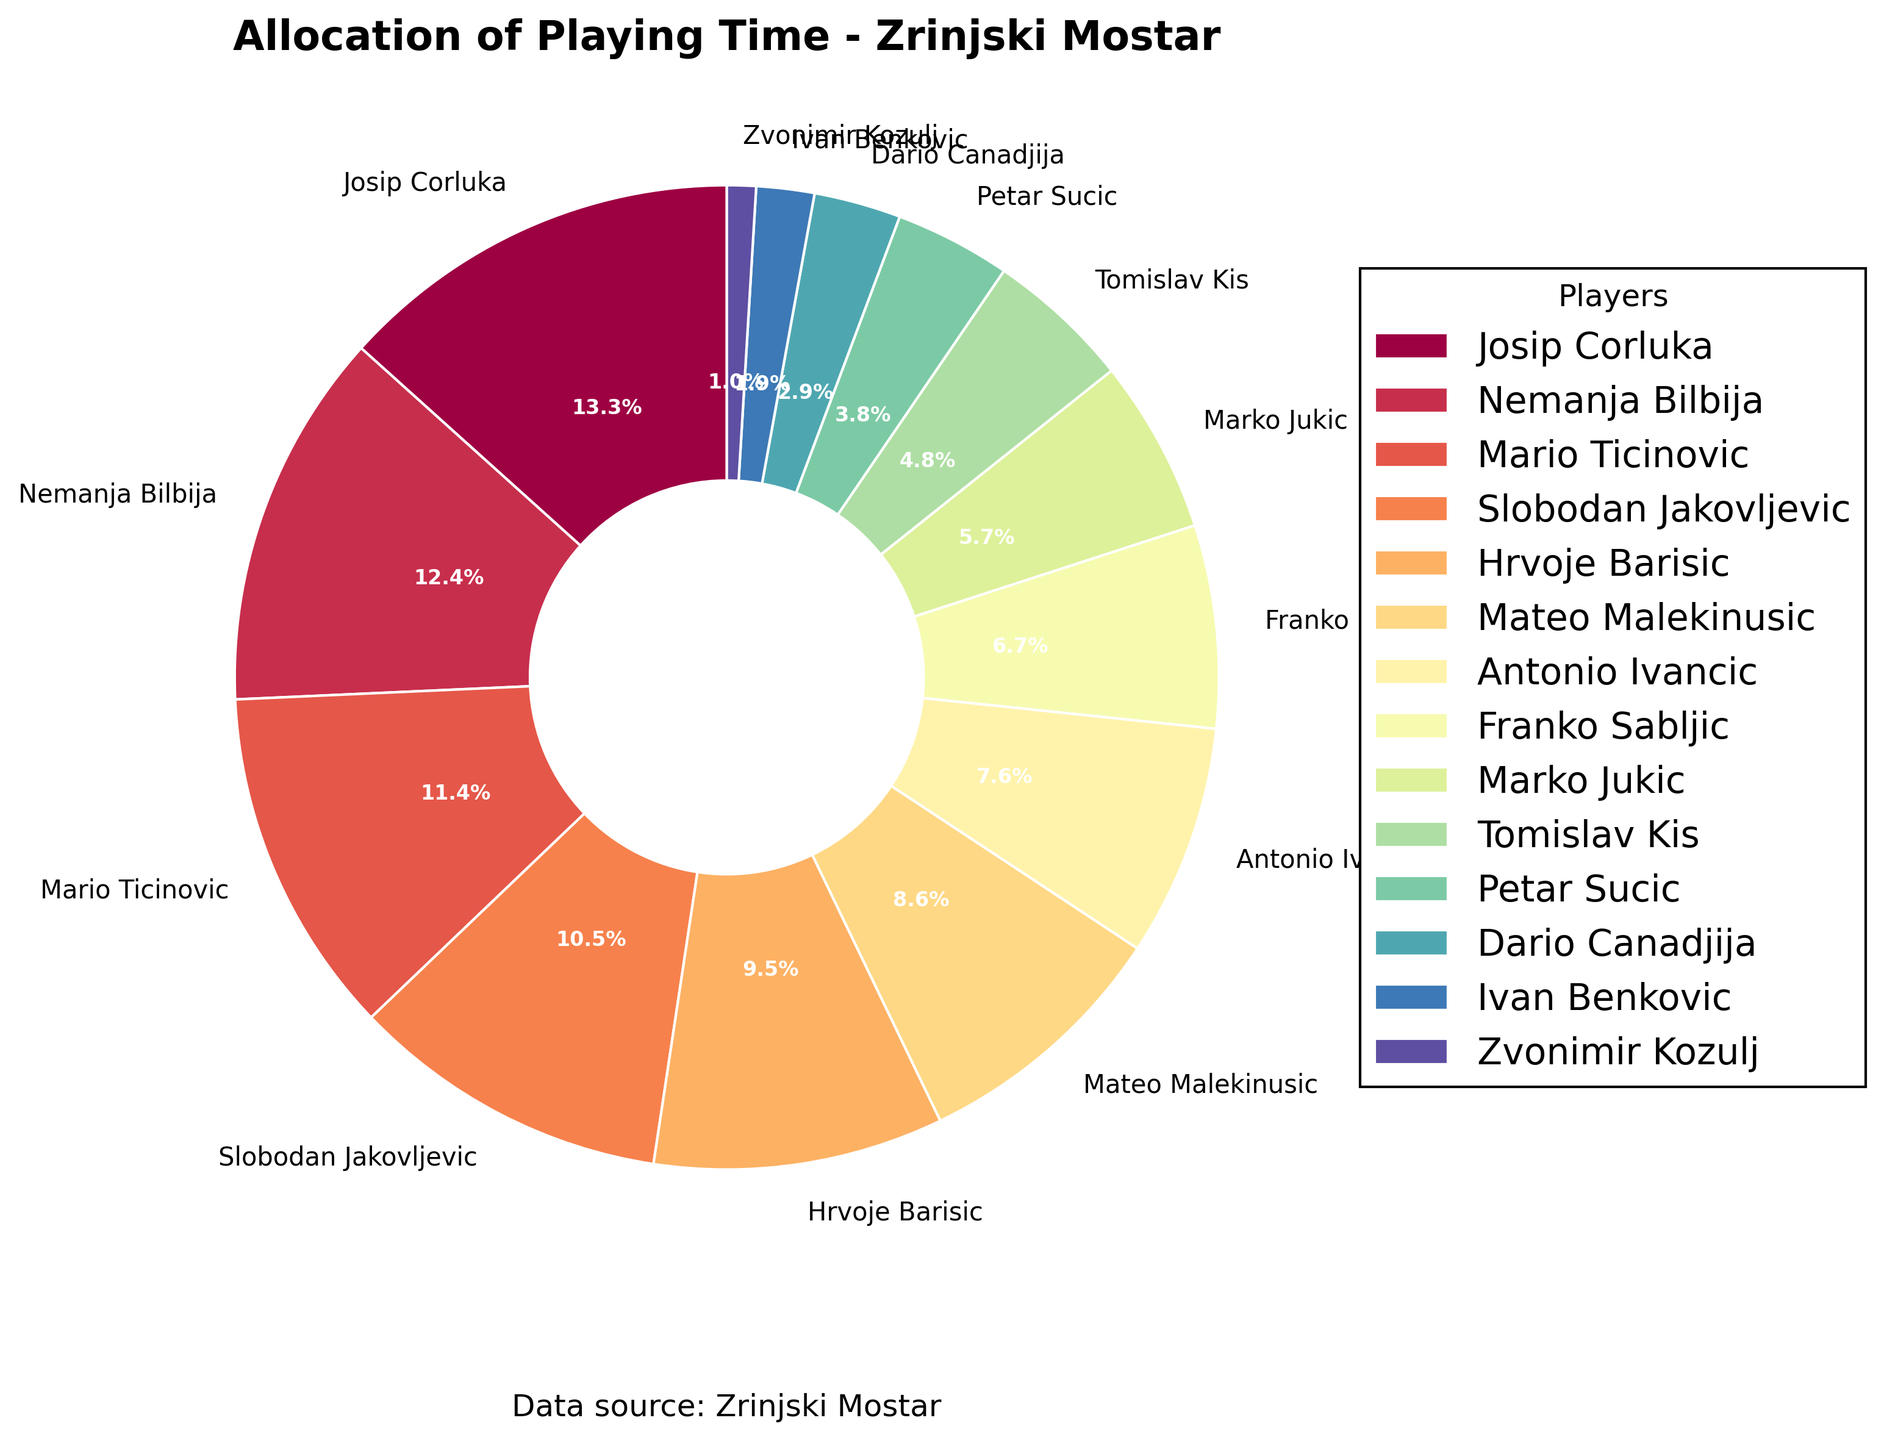Who played the most minutes? The player who had the largest segment in the pie chart represents the one who played the most minutes.
Answer: Josip Corluka Which player had the least playing time? The smallest segment in the pie chart corresponds to the player with the least playing time.
Answer: Zvonimir Kozulj How many players played more than 2000 minutes? Look at the segments for each player and count the ones that are labeled with more than 2000 minutes.
Answer: 3 Compare the playing time between Josip Corluka and Hrvoje Barisic. Who played more, and by how much? Find the segments for Josip Corluka and Hrvoje Barisic, then subtract Hrvoje Barisic's time from Josip Corluka's time.
Answer: Josip Corluka by 720 minutes What percentage of the total playing time is contributed by Slobodan Jakovljevic and Tomislav Kis combined? Sum up the minutes for Slobodan Jakovljevic and Tomislav Kis, then find this sum as a percentage of the total playing time, which is the sum of all players' minutes.
Answer: (1980 + 900) / 18900 ≈ 15.2% Which player has a segment that appears in the green spectrum on the pie chart? Identify the segment with a green hue. Color association is subjective but typically falls within a green appearance on the chart.
Answer: Dario Canadjija Is there any player who played exactly 10% of the total playing time? Calculate 10% of the total playing time, then check if any player's minutes match that value. 10% of 18900 is 1890; no player's minutes equal this value.
Answer: No What is the total playing time for the top three players combined? Add the minutes for the top three players: Josip Corluka, Nemanja Bilbija, and Mario Ticinovic.
Answer: 2520 + 2340 + 2160 = 7020 How does the playing time of Antonio Ivancic compare to that of Petar Sucic? Check the segments for both players and note that Antonio Ivancic's time is more than Petar Sucic's time. Antonio Ivancic has 1440 minutes while Petar Sucic has 720 minutes.
Answer: Antonio Ivancic played twice as much as Petar Sucic What is the average playing time per player? Sum all players' minutes and divide by the total number of players.
Answer: 18900 / 14 ≈ 1350 minutes 